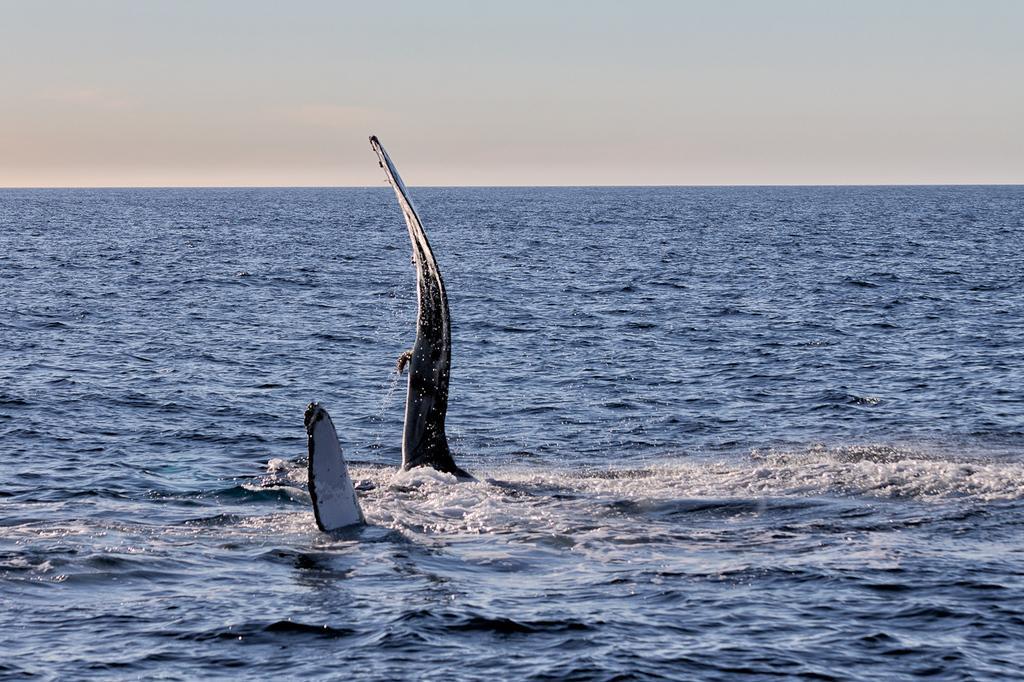In one or two sentences, can you explain what this image depicts? In this image I can see the aquatic animals in the water. The sky is in white color. 